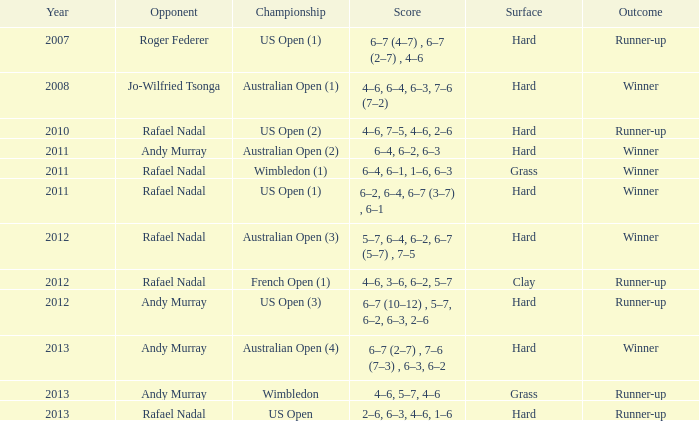What is the outcome of the 4–6, 6–4, 6–3, 7–6 (7–2) score? Winner. 